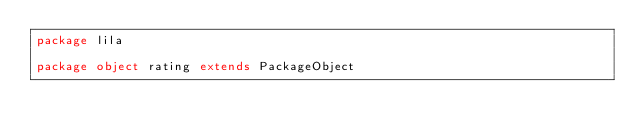Convert code to text. <code><loc_0><loc_0><loc_500><loc_500><_Scala_>package lila

package object rating extends PackageObject
</code> 